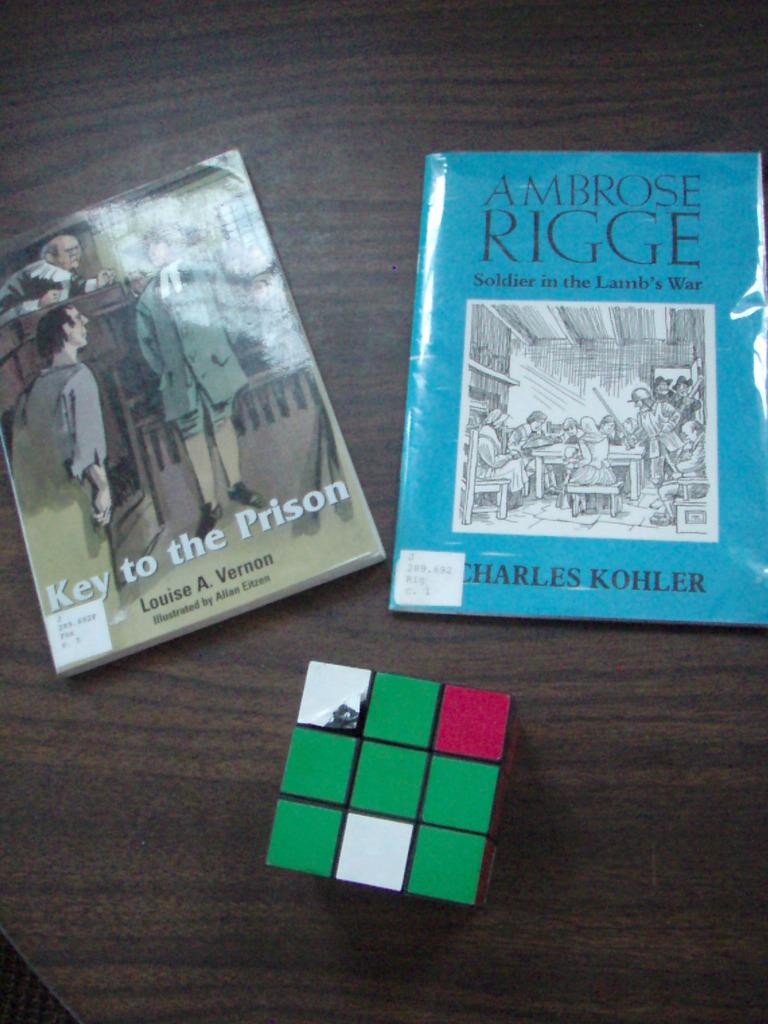<image>
Provide a brief description of the given image. Two books on a table which one is titled Key to the Prision and the other Ambrose  Rigge Solider in the Lamb's War, 